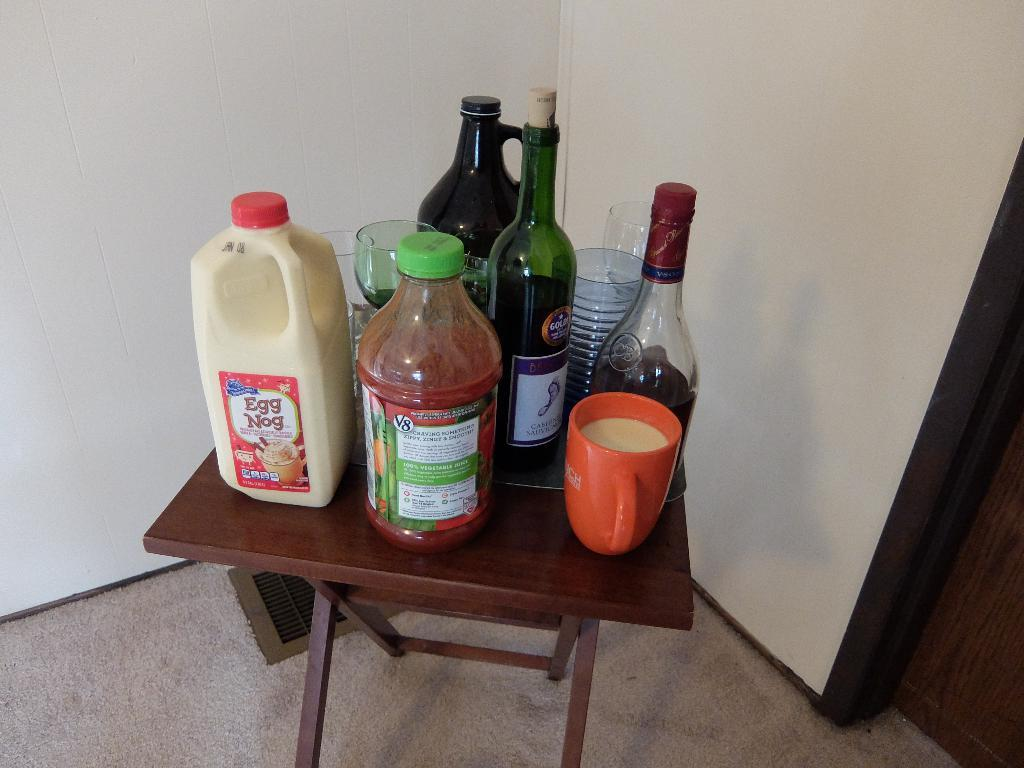<image>
Relay a brief, clear account of the picture shown. Milk, juice, and wine on a small brown table with cups and glasses 